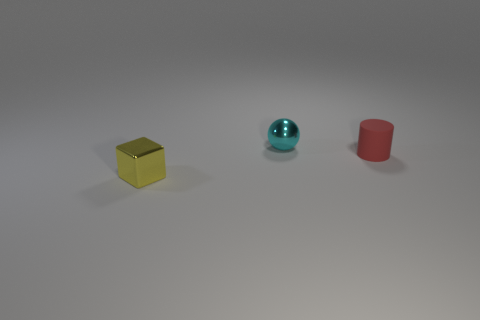What could these objects represent or be used for in a symbolic sense? The objects might symbolize various concepts. The cube could represent stability and order, as its equal faces and edges are associated with balance and equality. The sphere could symbolize unity and completeness, as it is a shape without beginning or end. The cylinder, with its strong base and open top, could represent growth or the potential to hold something. Together, these shapes might invoke a sense of harmony in diversity. 